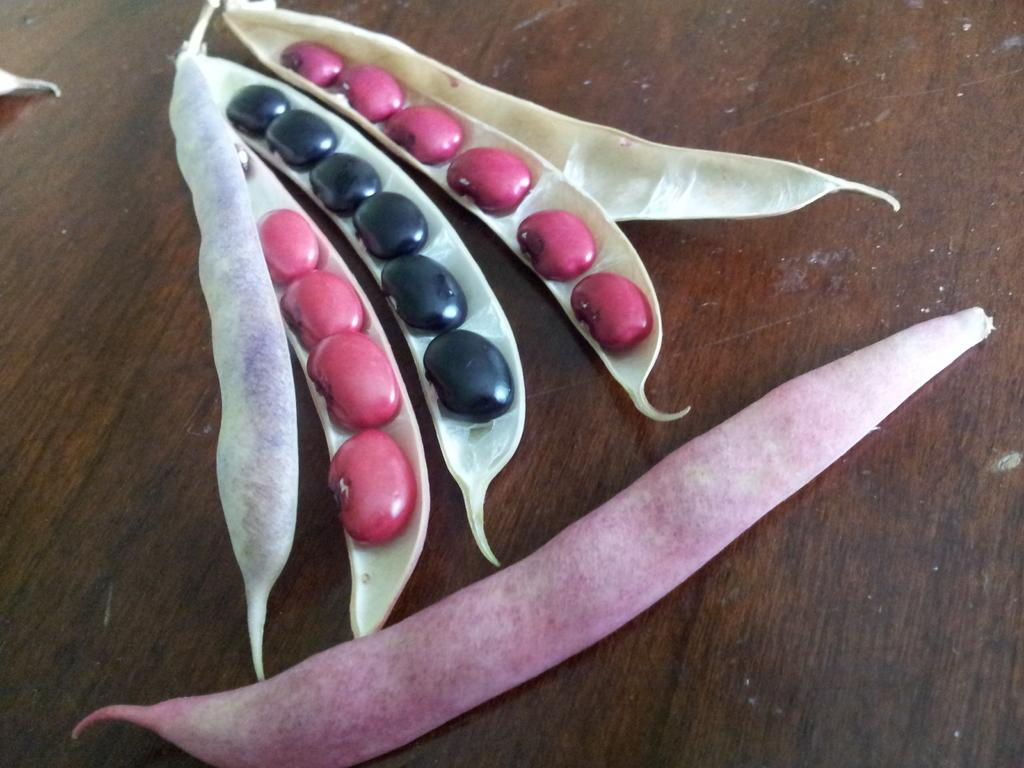What type of food is present in the image? There are peas in the image. What type of fruit is being served for breakfast in the image? There is no fruit or breakfast scene present in the image; it only features peas. How many snakes can be seen slithering through the peas in the image? There are no snakes present in the image; it only features peas. 